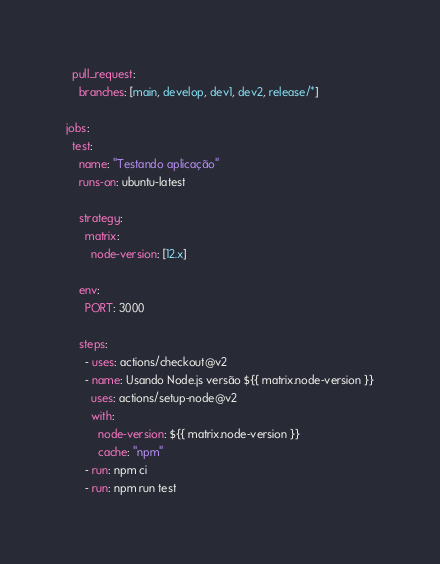Convert code to text. <code><loc_0><loc_0><loc_500><loc_500><_YAML_>  pull_request:
    branches: [main, develop, dev1, dev2, release/*]

jobs:
  test:
    name: "Testando aplicação"
    runs-on: ubuntu-latest

    strategy:
      matrix:
        node-version: [12.x]

    env:
      PORT: 3000

    steps:
      - uses: actions/checkout@v2
      - name: Usando Node.js versão ${{ matrix.node-version }}
        uses: actions/setup-node@v2
        with:
          node-version: ${{ matrix.node-version }}
          cache: "npm"
      - run: npm ci
      - run: npm run test
</code> 